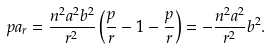Convert formula to latex. <formula><loc_0><loc_0><loc_500><loc_500>p a _ { r } = { \frac { n ^ { 2 } a ^ { 2 } b ^ { 2 } } { r ^ { 2 } } } \left ( { \frac { p } { r } } - 1 - { \frac { p } { r } } \right ) = - { \frac { n ^ { 2 } a ^ { 2 } } { r ^ { 2 } } } b ^ { 2 } .</formula> 